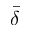<formula> <loc_0><loc_0><loc_500><loc_500>\bar { \delta }</formula> 